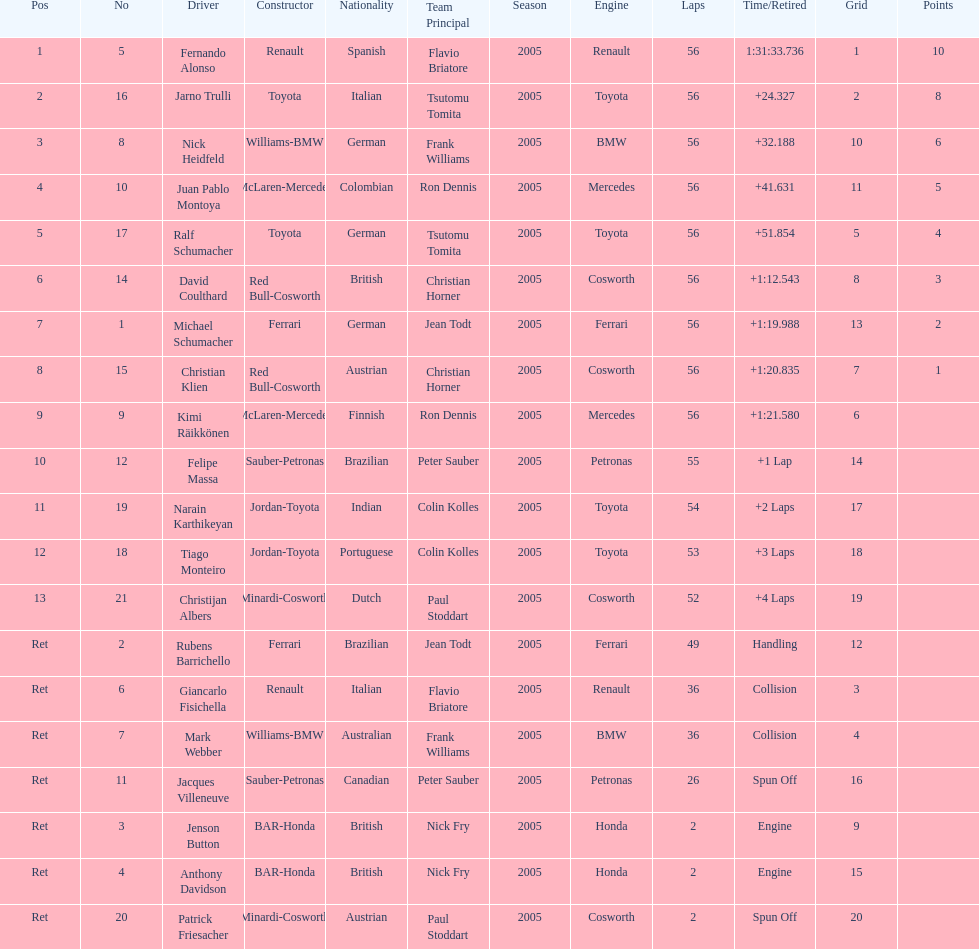Who was the last driver to actually finish the race? Christijan Albers. Could you parse the entire table as a dict? {'header': ['Pos', 'No', 'Driver', 'Constructor', 'Nationality', 'Team Principal', 'Season', 'Engine', 'Laps', 'Time/Retired', 'Grid', 'Points'], 'rows': [['1', '5', 'Fernando Alonso', 'Renault', 'Spanish', 'Flavio Briatore', '2005', 'Renault', '56', '1:31:33.736', '1', '10'], ['2', '16', 'Jarno Trulli', 'Toyota', 'Italian', 'Tsutomu Tomita', '2005', 'Toyota', '56', '+24.327', '2', '8'], ['3', '8', 'Nick Heidfeld', 'Williams-BMW', 'German', 'Frank Williams', '2005', 'BMW', '56', '+32.188', '10', '6'], ['4', '10', 'Juan Pablo Montoya', 'McLaren-Mercedes', 'Colombian', 'Ron Dennis', '2005', 'Mercedes', '56', '+41.631', '11', '5'], ['5', '17', 'Ralf Schumacher', 'Toyota', 'German', 'Tsutomu Tomita', '2005', 'Toyota', '56', '+51.854', '5', '4'], ['6', '14', 'David Coulthard', 'Red Bull-Cosworth', 'British', 'Christian Horner', '2005', 'Cosworth', '56', '+1:12.543', '8', '3'], ['7', '1', 'Michael Schumacher', 'Ferrari', 'German', 'Jean Todt', '2005', 'Ferrari', '56', '+1:19.988', '13', '2'], ['8', '15', 'Christian Klien', 'Red Bull-Cosworth', 'Austrian', 'Christian Horner', '2005', 'Cosworth', '56', '+1:20.835', '7', '1'], ['9', '9', 'Kimi Räikkönen', 'McLaren-Mercedes', 'Finnish', 'Ron Dennis', '2005', 'Mercedes', '56', '+1:21.580', '6', ''], ['10', '12', 'Felipe Massa', 'Sauber-Petronas', 'Brazilian', 'Peter Sauber', '2005', 'Petronas', '55', '+1 Lap', '14', ''], ['11', '19', 'Narain Karthikeyan', 'Jordan-Toyota', 'Indian', 'Colin Kolles', '2005', 'Toyota', '54', '+2 Laps', '17', ''], ['12', '18', 'Tiago Monteiro', 'Jordan-Toyota', 'Portuguese', 'Colin Kolles', '2005', 'Toyota', '53', '+3 Laps', '18', ''], ['13', '21', 'Christijan Albers', 'Minardi-Cosworth', 'Dutch', 'Paul Stoddart', '2005', 'Cosworth', '52', '+4 Laps', '19', ''], ['Ret', '2', 'Rubens Barrichello', 'Ferrari', 'Brazilian', 'Jean Todt', '2005', 'Ferrari', '49', 'Handling', '12', ''], ['Ret', '6', 'Giancarlo Fisichella', 'Renault', 'Italian', 'Flavio Briatore', '2005', 'Renault', '36', 'Collision', '3', ''], ['Ret', '7', 'Mark Webber', 'Williams-BMW', 'Australian', 'Frank Williams', '2005', 'BMW', '36', 'Collision', '4', ''], ['Ret', '11', 'Jacques Villeneuve', 'Sauber-Petronas', 'Canadian', 'Peter Sauber', '2005', 'Petronas', '26', 'Spun Off', '16', ''], ['Ret', '3', 'Jenson Button', 'BAR-Honda', 'British', 'Nick Fry', '2005', 'Honda', '2', 'Engine', '9', ''], ['Ret', '4', 'Anthony Davidson', 'BAR-Honda', 'British', 'Nick Fry', '2005', 'Honda', '2', 'Engine', '15', ''], ['Ret', '20', 'Patrick Friesacher', 'Minardi-Cosworth', 'Austrian', 'Paul Stoddart', '2005', 'Cosworth', '2', 'Spun Off', '20', '']]} 